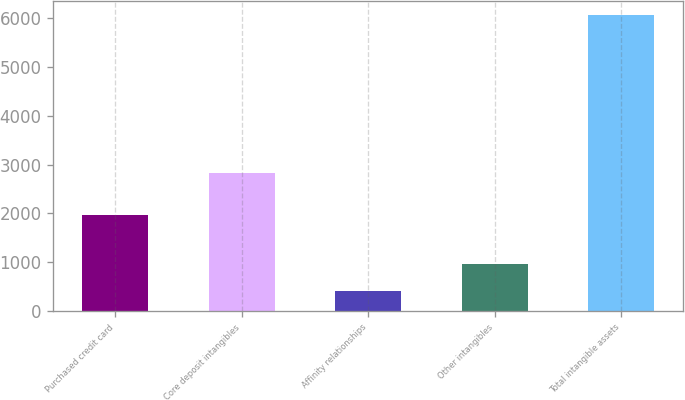Convert chart to OTSL. <chart><loc_0><loc_0><loc_500><loc_500><bar_chart><fcel>Purchased credit card<fcel>Core deposit intangibles<fcel>Affinity relationships<fcel>Other intangibles<fcel>Total intangible assets<nl><fcel>1970<fcel>2828<fcel>406<fcel>971<fcel>6056<nl></chart> 